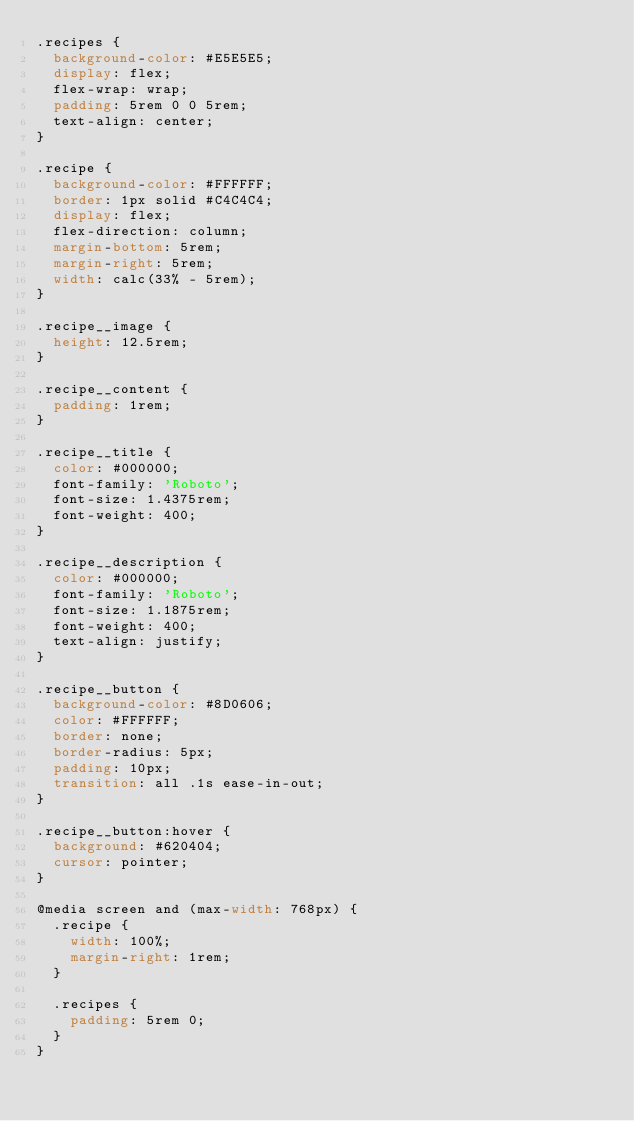<code> <loc_0><loc_0><loc_500><loc_500><_CSS_>.recipes {
  background-color: #E5E5E5;
  display: flex;
  flex-wrap: wrap;
  padding: 5rem 0 0 5rem;
  text-align: center;
}

.recipe {
  background-color: #FFFFFF;
  border: 1px solid #C4C4C4;
  display: flex;
  flex-direction: column;
  margin-bottom: 5rem;
  margin-right: 5rem;
  width: calc(33% - 5rem);
}

.recipe__image {
  height: 12.5rem;
}

.recipe__content {
  padding: 1rem;
}

.recipe__title {
  color: #000000;
  font-family: 'Roboto';
  font-size: 1.4375rem;
  font-weight: 400;
}

.recipe__description {
  color: #000000;
  font-family: 'Roboto';
  font-size: 1.1875rem;
  font-weight: 400;
  text-align: justify;
}

.recipe__button {
  background-color: #8D0606;
  color: #FFFFFF;
  border: none;
  border-radius: 5px;
  padding: 10px;
  transition: all .1s ease-in-out;
}

.recipe__button:hover {
  background: #620404;
  cursor: pointer;
}

@media screen and (max-width: 768px) {
  .recipe {
    width: 100%;
    margin-right: 1rem;
  }

  .recipes {
    padding: 5rem 0;
  }
}</code> 